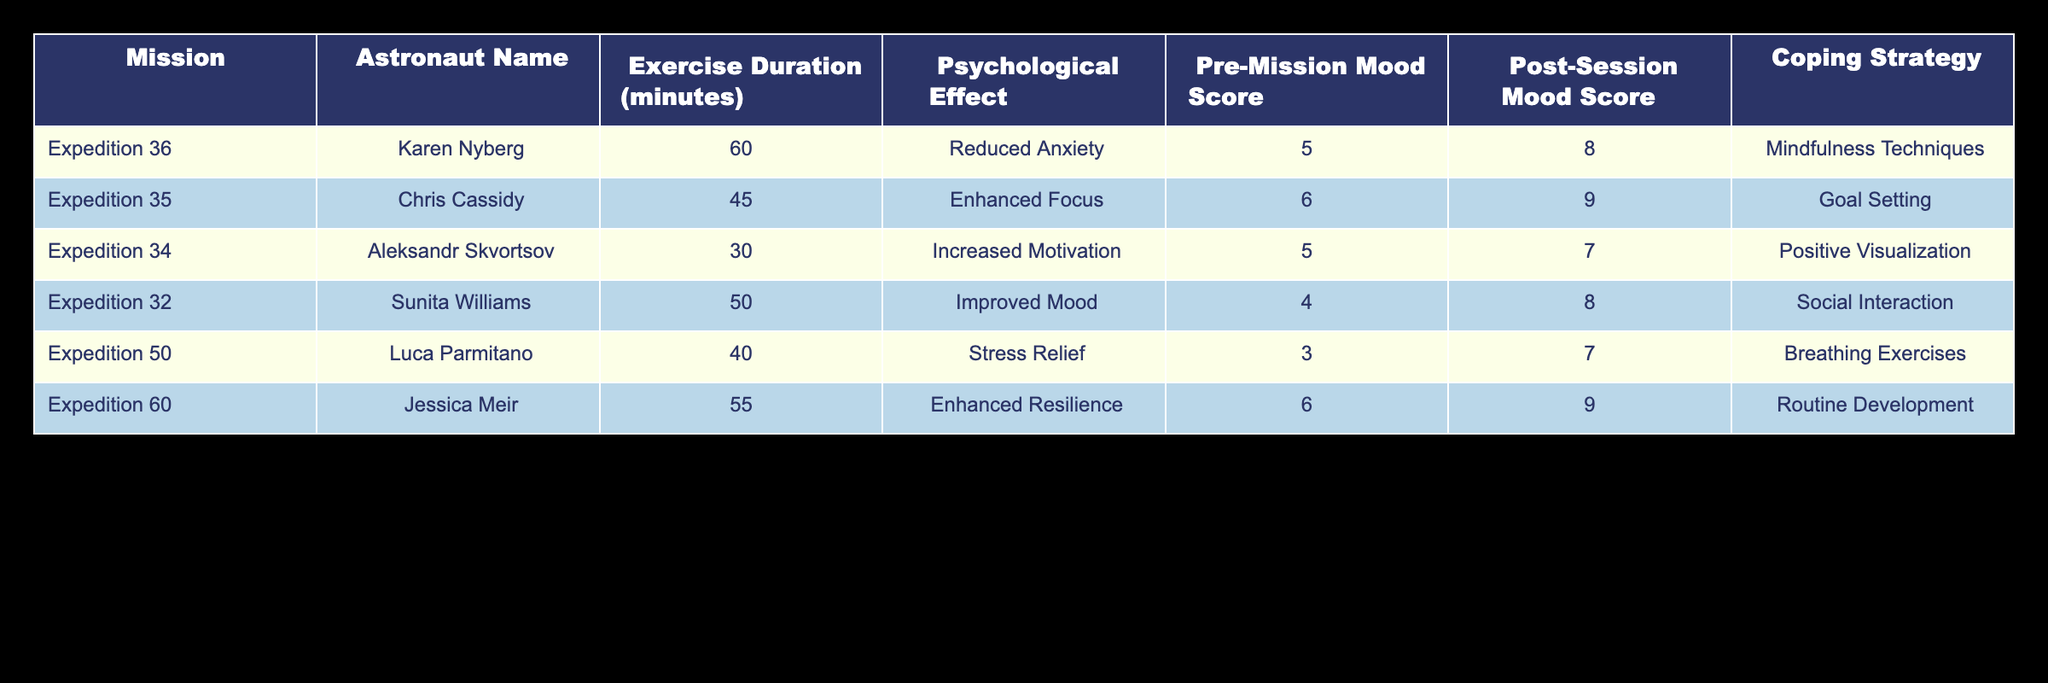What is the psychological effect reported by Jessica Meir? The table shows that Jessica Meir reported "Enhanced Resilience" as her psychological effect during her exercise session on Expedition 60.
Answer: Enhanced Resilience Which astronaut had the longest exercise duration? By comparing the "Exercise Duration" column, Karen Nyberg from Expedition 36 has the longest exercise duration of 60 minutes.
Answer: Karen Nyberg What was the average Pre-Mission Mood Score of the astronauts? To find the average, sum the Pre-Mission Mood Scores (5 + 6 + 5 + 4 + 3 + 6 = 29) and divide by the number of astronauts (6). Thus, the average Pre-Mission Mood Score is 29 / 6 = 4.83.
Answer: 4.83 Did any astronaut report a Pre-Mission Mood Score of 3? The table indicates that the lowest Pre-Mission Mood Score was 3, which was reported by Luca Parmitano during Expedition 50. Therefore, the answer is yes.
Answer: Yes Which coping strategy was most commonly used amongst the astronauts? Analyzing the coping strategies, different astronauts used different methods. However, there is a variety of strategies shown and no single strategy is repeated, indicating all are unique.
Answer: None How did the Post-Session Mood Score change for Chris Cassidy? Chris Cassidy had a Pre-Mission Mood Score of 6 and a Post-Session Mood Score of 9. The difference (9 - 6 = 3) indicates an increase of 3 points after the session.
Answer: Increased by 3 points Is there any astronaut who had both a Pre-Mission and Post-Session Mood Score over 8? Considering the data, both Sunita Williams (Pre=4, Post=8) and Jessica Meir (Pre=6, Post=9) did not have Pre-Mission Mood Scores above 8. Thus, the answer is no.
Answer: No What is the combined Exercise Duration of all astronauts? To find the combined Exercise Duration, sum the durations: (60 + 45 + 30 + 50 + 40 + 55) = 280 minutes.
Answer: 280 Which astronaut reported Stress Relief as a psychological effect? According to the table, Luca Parmitano reported "Stress Relief" during Expedition 50 as his psychological effect after exercise.
Answer: Luca Parmitano 